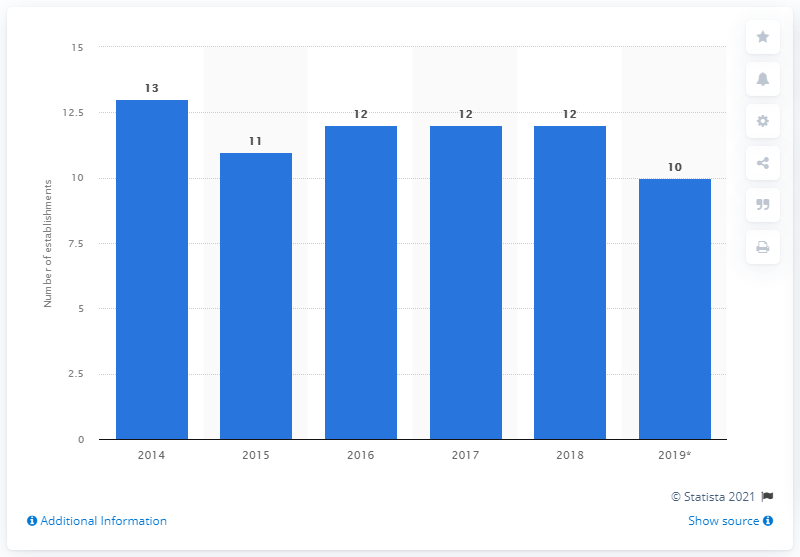Highlight a few significant elements in this photo. In 2019, there were approximately 10 establishments in Colombia that produced sports equipment. 